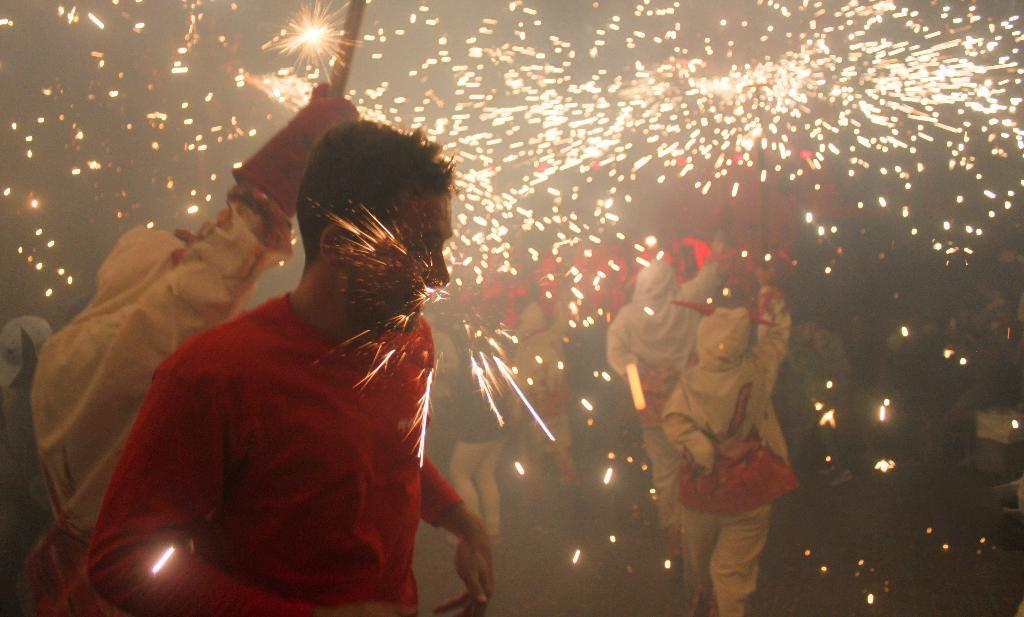What is the primary location of the people in the image? The people are standing on the ground in the image. What additional visual element can be seen at the top of the image? There are sparkles visible at the top of the image. What type of fruit is being held by the ghost in the image? There is no ghost or fruit present in the image. 